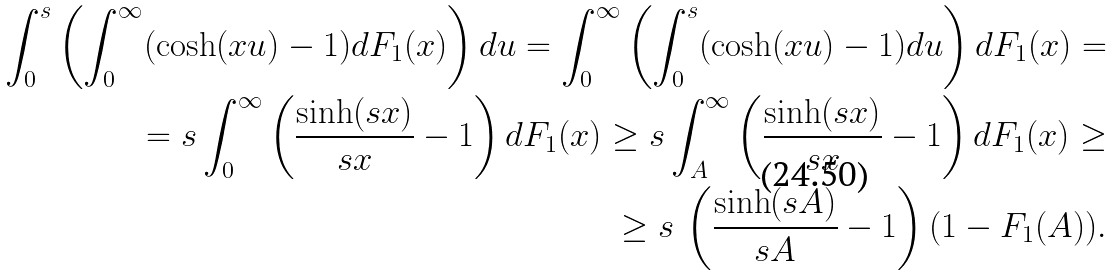Convert formula to latex. <formula><loc_0><loc_0><loc_500><loc_500>\int _ { 0 } ^ { s } \left ( \int _ { 0 } ^ { \infty } ( \cosh ( x u ) - 1 ) d F _ { 1 } ( x ) \right ) d u = \int _ { 0 } ^ { \infty } \left ( \int _ { 0 } ^ { s } ( \cosh ( x u ) - 1 ) d u \right ) d F _ { 1 } ( x ) = \\ = s \int _ { 0 } ^ { \infty } \left ( \frac { \sinh ( s x ) } { s x } - 1 \right ) d F _ { 1 } ( x ) \geq s \int _ { A } ^ { \infty } \left ( \frac { \sinh ( s x ) } { s x } - 1 \right ) d F _ { 1 } ( x ) \geq \\ \geq s \, \left ( \frac { \sinh ( s A ) } { s A } - 1 \right ) ( 1 - F _ { 1 } ( A ) ) .</formula> 